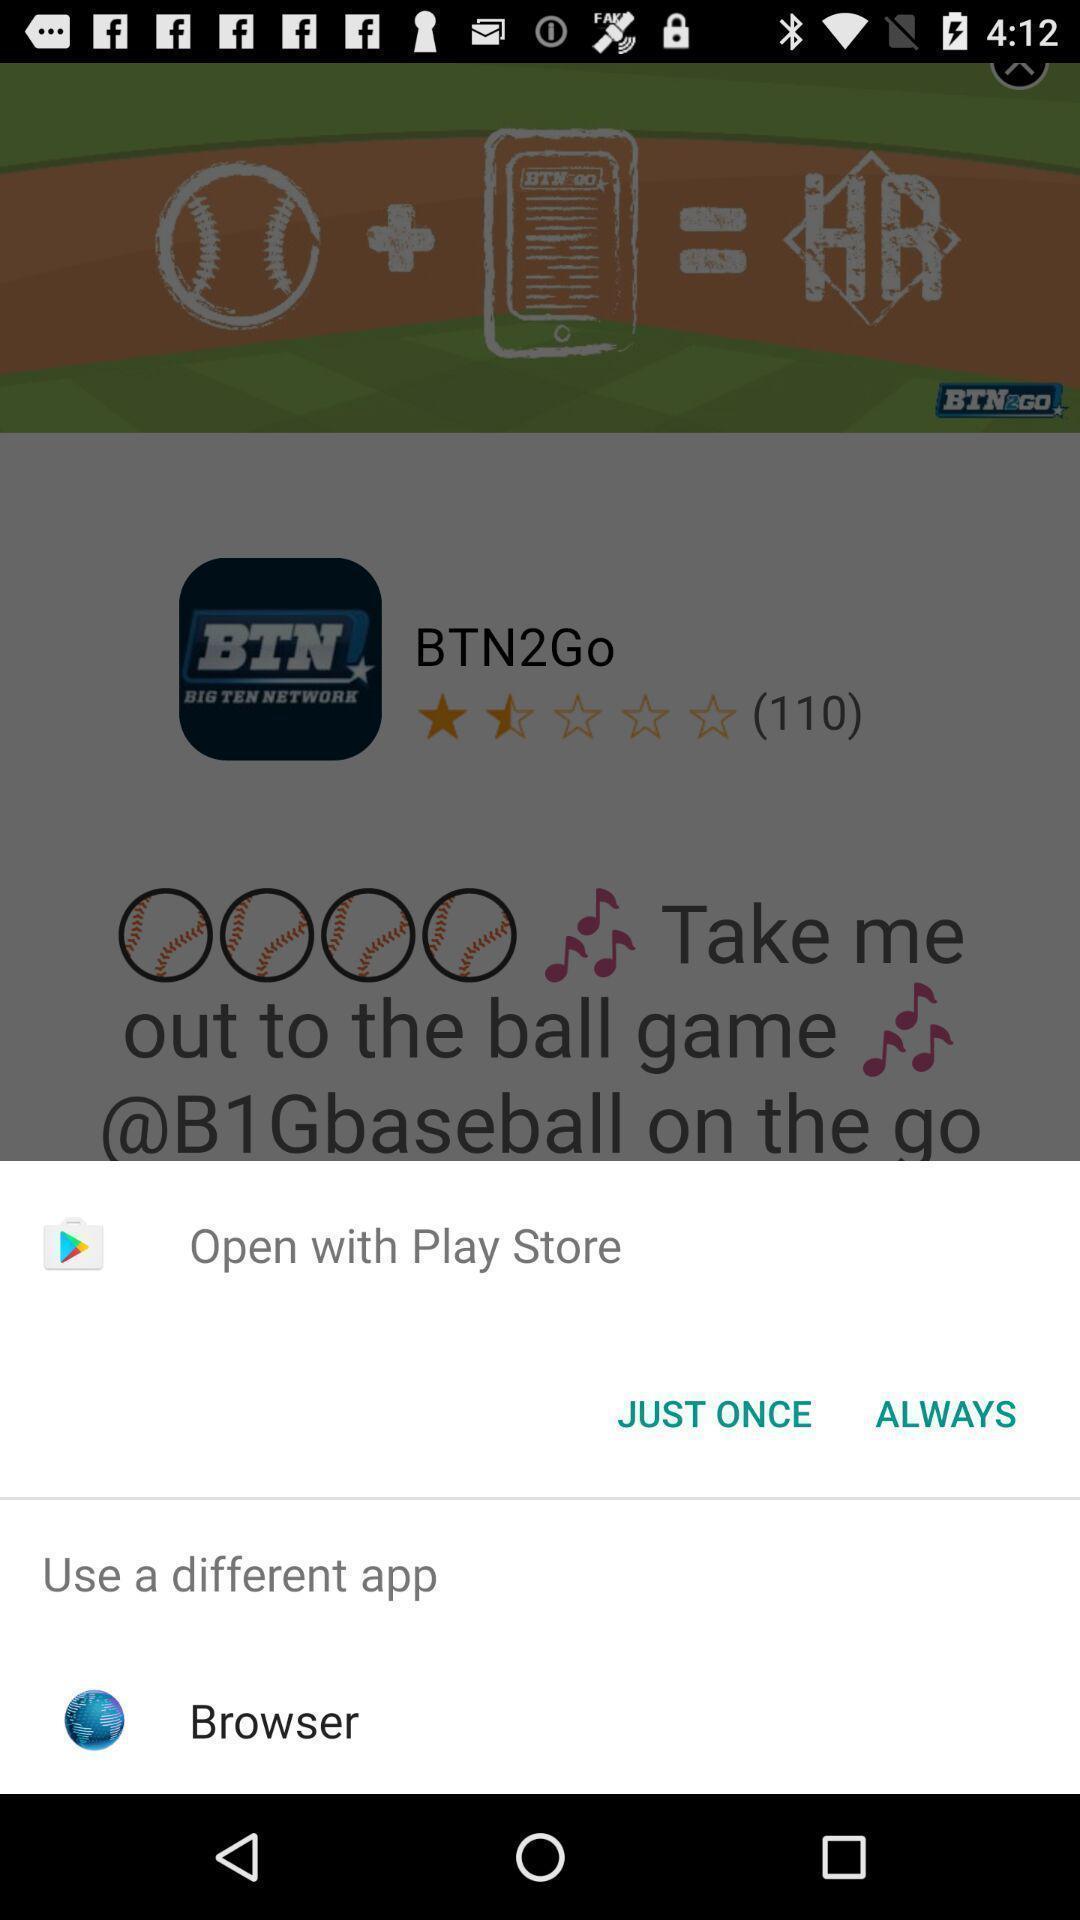What can you discern from this picture? Pop up page for opening through different apps. 